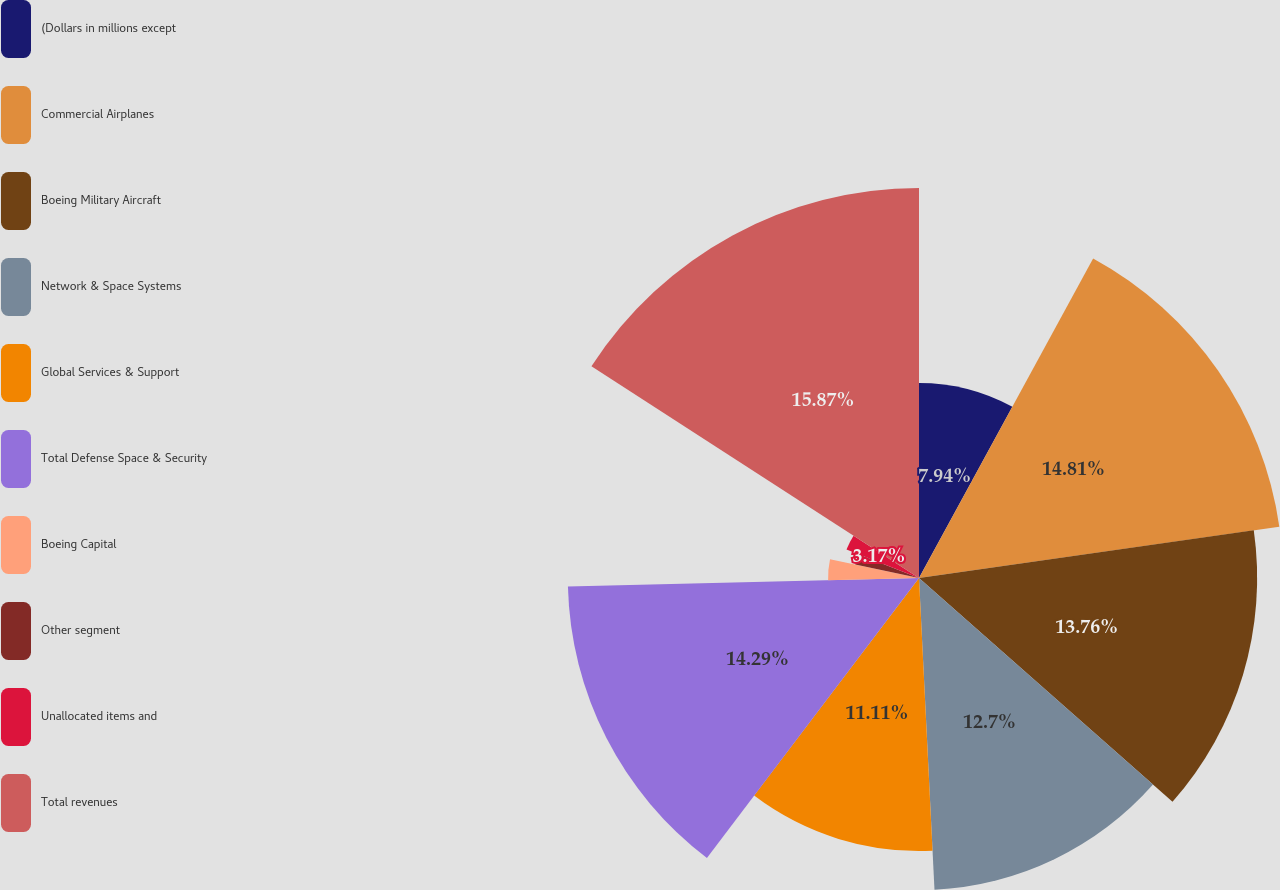Convert chart to OTSL. <chart><loc_0><loc_0><loc_500><loc_500><pie_chart><fcel>(Dollars in millions except<fcel>Commercial Airplanes<fcel>Boeing Military Aircraft<fcel>Network & Space Systems<fcel>Global Services & Support<fcel>Total Defense Space & Security<fcel>Boeing Capital<fcel>Other segment<fcel>Unallocated items and<fcel>Total revenues<nl><fcel>7.94%<fcel>14.81%<fcel>13.76%<fcel>12.7%<fcel>11.11%<fcel>14.29%<fcel>3.7%<fcel>2.65%<fcel>3.17%<fcel>15.87%<nl></chart> 